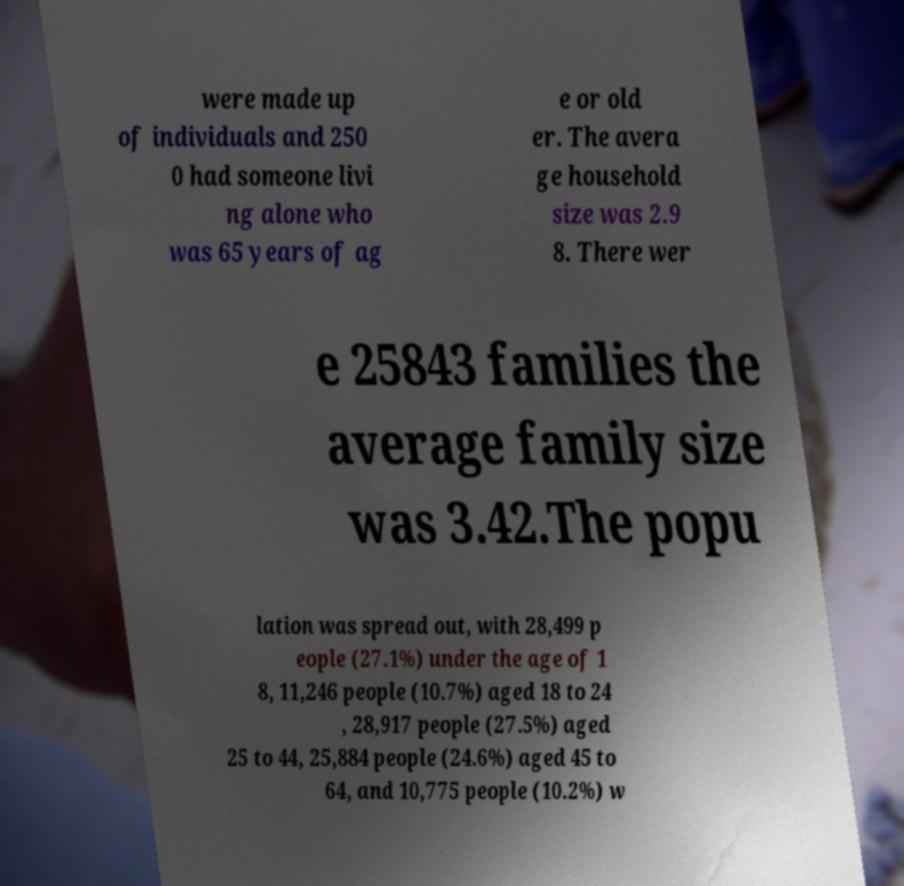There's text embedded in this image that I need extracted. Can you transcribe it verbatim? were made up of individuals and 250 0 had someone livi ng alone who was 65 years of ag e or old er. The avera ge household size was 2.9 8. There wer e 25843 families the average family size was 3.42.The popu lation was spread out, with 28,499 p eople (27.1%) under the age of 1 8, 11,246 people (10.7%) aged 18 to 24 , 28,917 people (27.5%) aged 25 to 44, 25,884 people (24.6%) aged 45 to 64, and 10,775 people (10.2%) w 